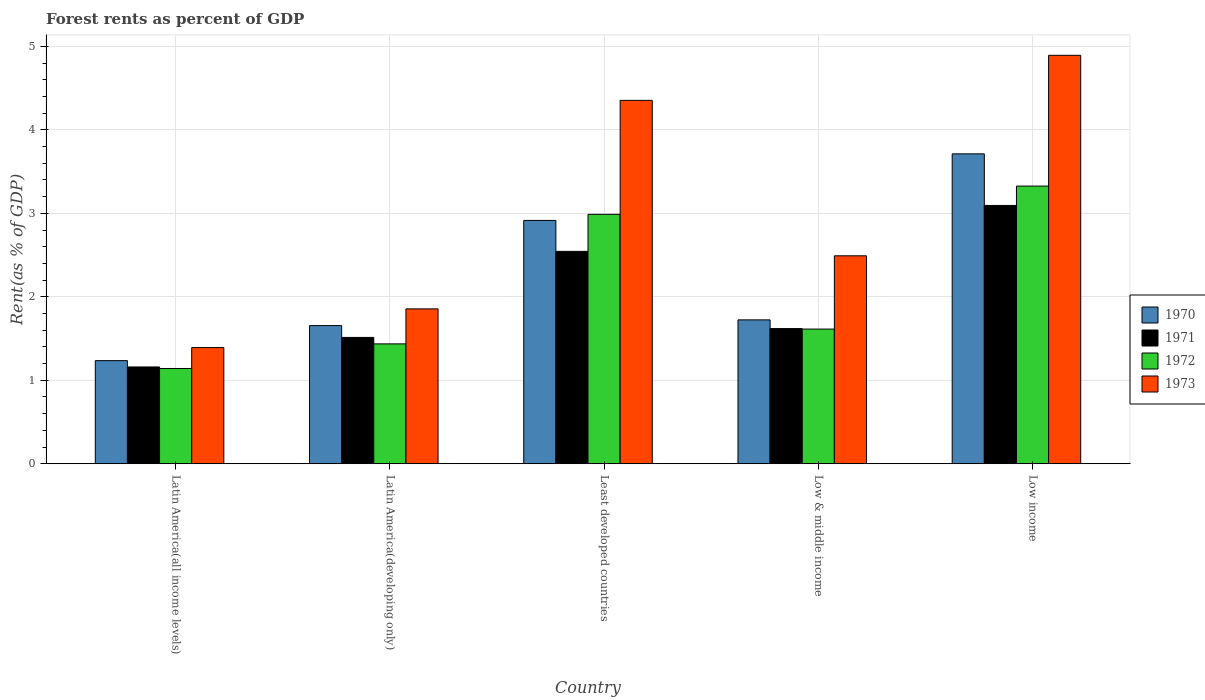How many groups of bars are there?
Make the answer very short. 5. Are the number of bars on each tick of the X-axis equal?
Provide a succinct answer. Yes. How many bars are there on the 4th tick from the left?
Offer a terse response. 4. How many bars are there on the 3rd tick from the right?
Give a very brief answer. 4. In how many cases, is the number of bars for a given country not equal to the number of legend labels?
Ensure brevity in your answer.  0. What is the forest rent in 1972 in Least developed countries?
Give a very brief answer. 2.99. Across all countries, what is the maximum forest rent in 1971?
Give a very brief answer. 3.09. Across all countries, what is the minimum forest rent in 1970?
Make the answer very short. 1.24. In which country was the forest rent in 1971 maximum?
Provide a succinct answer. Low income. In which country was the forest rent in 1971 minimum?
Offer a terse response. Latin America(all income levels). What is the total forest rent in 1970 in the graph?
Offer a terse response. 11.24. What is the difference between the forest rent in 1973 in Least developed countries and that in Low income?
Make the answer very short. -0.54. What is the difference between the forest rent in 1973 in Latin America(all income levels) and the forest rent in 1971 in Least developed countries?
Your response must be concise. -1.15. What is the average forest rent in 1970 per country?
Keep it short and to the point. 2.25. What is the difference between the forest rent of/in 1973 and forest rent of/in 1971 in Latin America(developing only)?
Give a very brief answer. 0.34. In how many countries, is the forest rent in 1970 greater than 0.4 %?
Give a very brief answer. 5. What is the ratio of the forest rent in 1973 in Latin America(developing only) to that in Low income?
Your response must be concise. 0.38. Is the forest rent in 1971 in Latin America(all income levels) less than that in Low income?
Offer a very short reply. Yes. What is the difference between the highest and the second highest forest rent in 1970?
Make the answer very short. -1.19. What is the difference between the highest and the lowest forest rent in 1970?
Your answer should be compact. 2.48. In how many countries, is the forest rent in 1970 greater than the average forest rent in 1970 taken over all countries?
Provide a succinct answer. 2. Is it the case that in every country, the sum of the forest rent in 1972 and forest rent in 1970 is greater than the sum of forest rent in 1971 and forest rent in 1973?
Your response must be concise. No. How many bars are there?
Offer a very short reply. 20. How many countries are there in the graph?
Your answer should be very brief. 5. What is the difference between two consecutive major ticks on the Y-axis?
Make the answer very short. 1. Does the graph contain any zero values?
Keep it short and to the point. No. How many legend labels are there?
Give a very brief answer. 4. What is the title of the graph?
Your response must be concise. Forest rents as percent of GDP. What is the label or title of the X-axis?
Give a very brief answer. Country. What is the label or title of the Y-axis?
Provide a short and direct response. Rent(as % of GDP). What is the Rent(as % of GDP) in 1970 in Latin America(all income levels)?
Offer a terse response. 1.24. What is the Rent(as % of GDP) in 1971 in Latin America(all income levels)?
Give a very brief answer. 1.16. What is the Rent(as % of GDP) in 1972 in Latin America(all income levels)?
Ensure brevity in your answer.  1.14. What is the Rent(as % of GDP) in 1973 in Latin America(all income levels)?
Provide a succinct answer. 1.39. What is the Rent(as % of GDP) of 1970 in Latin America(developing only)?
Provide a short and direct response. 1.66. What is the Rent(as % of GDP) in 1971 in Latin America(developing only)?
Your response must be concise. 1.51. What is the Rent(as % of GDP) of 1972 in Latin America(developing only)?
Make the answer very short. 1.44. What is the Rent(as % of GDP) of 1973 in Latin America(developing only)?
Provide a short and direct response. 1.86. What is the Rent(as % of GDP) of 1970 in Least developed countries?
Offer a very short reply. 2.92. What is the Rent(as % of GDP) in 1971 in Least developed countries?
Ensure brevity in your answer.  2.54. What is the Rent(as % of GDP) in 1972 in Least developed countries?
Offer a terse response. 2.99. What is the Rent(as % of GDP) of 1973 in Least developed countries?
Your answer should be compact. 4.35. What is the Rent(as % of GDP) in 1970 in Low & middle income?
Keep it short and to the point. 1.72. What is the Rent(as % of GDP) of 1971 in Low & middle income?
Your answer should be very brief. 1.62. What is the Rent(as % of GDP) in 1972 in Low & middle income?
Your answer should be compact. 1.61. What is the Rent(as % of GDP) in 1973 in Low & middle income?
Your answer should be very brief. 2.49. What is the Rent(as % of GDP) in 1970 in Low income?
Your response must be concise. 3.71. What is the Rent(as % of GDP) in 1971 in Low income?
Make the answer very short. 3.09. What is the Rent(as % of GDP) of 1972 in Low income?
Your answer should be very brief. 3.33. What is the Rent(as % of GDP) in 1973 in Low income?
Offer a very short reply. 4.89. Across all countries, what is the maximum Rent(as % of GDP) of 1970?
Your answer should be compact. 3.71. Across all countries, what is the maximum Rent(as % of GDP) of 1971?
Provide a succinct answer. 3.09. Across all countries, what is the maximum Rent(as % of GDP) of 1972?
Provide a succinct answer. 3.33. Across all countries, what is the maximum Rent(as % of GDP) of 1973?
Your answer should be compact. 4.89. Across all countries, what is the minimum Rent(as % of GDP) of 1970?
Make the answer very short. 1.24. Across all countries, what is the minimum Rent(as % of GDP) of 1971?
Offer a very short reply. 1.16. Across all countries, what is the minimum Rent(as % of GDP) in 1972?
Offer a very short reply. 1.14. Across all countries, what is the minimum Rent(as % of GDP) in 1973?
Keep it short and to the point. 1.39. What is the total Rent(as % of GDP) of 1970 in the graph?
Your answer should be compact. 11.24. What is the total Rent(as % of GDP) of 1971 in the graph?
Provide a short and direct response. 9.93. What is the total Rent(as % of GDP) of 1972 in the graph?
Provide a succinct answer. 10.51. What is the total Rent(as % of GDP) in 1973 in the graph?
Provide a succinct answer. 14.99. What is the difference between the Rent(as % of GDP) of 1970 in Latin America(all income levels) and that in Latin America(developing only)?
Your answer should be very brief. -0.42. What is the difference between the Rent(as % of GDP) in 1971 in Latin America(all income levels) and that in Latin America(developing only)?
Your response must be concise. -0.35. What is the difference between the Rent(as % of GDP) of 1972 in Latin America(all income levels) and that in Latin America(developing only)?
Your answer should be very brief. -0.29. What is the difference between the Rent(as % of GDP) of 1973 in Latin America(all income levels) and that in Latin America(developing only)?
Offer a very short reply. -0.46. What is the difference between the Rent(as % of GDP) of 1970 in Latin America(all income levels) and that in Least developed countries?
Your response must be concise. -1.68. What is the difference between the Rent(as % of GDP) in 1971 in Latin America(all income levels) and that in Least developed countries?
Provide a short and direct response. -1.39. What is the difference between the Rent(as % of GDP) in 1972 in Latin America(all income levels) and that in Least developed countries?
Give a very brief answer. -1.85. What is the difference between the Rent(as % of GDP) of 1973 in Latin America(all income levels) and that in Least developed countries?
Offer a very short reply. -2.96. What is the difference between the Rent(as % of GDP) in 1970 in Latin America(all income levels) and that in Low & middle income?
Your answer should be very brief. -0.49. What is the difference between the Rent(as % of GDP) of 1971 in Latin America(all income levels) and that in Low & middle income?
Offer a very short reply. -0.46. What is the difference between the Rent(as % of GDP) in 1972 in Latin America(all income levels) and that in Low & middle income?
Provide a short and direct response. -0.47. What is the difference between the Rent(as % of GDP) of 1973 in Latin America(all income levels) and that in Low & middle income?
Your answer should be very brief. -1.1. What is the difference between the Rent(as % of GDP) in 1970 in Latin America(all income levels) and that in Low income?
Ensure brevity in your answer.  -2.48. What is the difference between the Rent(as % of GDP) of 1971 in Latin America(all income levels) and that in Low income?
Your answer should be compact. -1.94. What is the difference between the Rent(as % of GDP) of 1972 in Latin America(all income levels) and that in Low income?
Give a very brief answer. -2.19. What is the difference between the Rent(as % of GDP) of 1973 in Latin America(all income levels) and that in Low income?
Your answer should be compact. -3.5. What is the difference between the Rent(as % of GDP) of 1970 in Latin America(developing only) and that in Least developed countries?
Keep it short and to the point. -1.26. What is the difference between the Rent(as % of GDP) in 1971 in Latin America(developing only) and that in Least developed countries?
Keep it short and to the point. -1.03. What is the difference between the Rent(as % of GDP) in 1972 in Latin America(developing only) and that in Least developed countries?
Ensure brevity in your answer.  -1.55. What is the difference between the Rent(as % of GDP) in 1973 in Latin America(developing only) and that in Least developed countries?
Your response must be concise. -2.5. What is the difference between the Rent(as % of GDP) in 1970 in Latin America(developing only) and that in Low & middle income?
Provide a short and direct response. -0.07. What is the difference between the Rent(as % of GDP) of 1971 in Latin America(developing only) and that in Low & middle income?
Keep it short and to the point. -0.11. What is the difference between the Rent(as % of GDP) in 1972 in Latin America(developing only) and that in Low & middle income?
Your answer should be compact. -0.18. What is the difference between the Rent(as % of GDP) in 1973 in Latin America(developing only) and that in Low & middle income?
Keep it short and to the point. -0.64. What is the difference between the Rent(as % of GDP) in 1970 in Latin America(developing only) and that in Low income?
Give a very brief answer. -2.06. What is the difference between the Rent(as % of GDP) in 1971 in Latin America(developing only) and that in Low income?
Give a very brief answer. -1.58. What is the difference between the Rent(as % of GDP) in 1972 in Latin America(developing only) and that in Low income?
Provide a succinct answer. -1.89. What is the difference between the Rent(as % of GDP) of 1973 in Latin America(developing only) and that in Low income?
Your answer should be compact. -3.04. What is the difference between the Rent(as % of GDP) in 1970 in Least developed countries and that in Low & middle income?
Provide a succinct answer. 1.19. What is the difference between the Rent(as % of GDP) of 1971 in Least developed countries and that in Low & middle income?
Ensure brevity in your answer.  0.93. What is the difference between the Rent(as % of GDP) in 1972 in Least developed countries and that in Low & middle income?
Offer a very short reply. 1.37. What is the difference between the Rent(as % of GDP) in 1973 in Least developed countries and that in Low & middle income?
Offer a terse response. 1.86. What is the difference between the Rent(as % of GDP) of 1970 in Least developed countries and that in Low income?
Your answer should be compact. -0.8. What is the difference between the Rent(as % of GDP) in 1971 in Least developed countries and that in Low income?
Provide a succinct answer. -0.55. What is the difference between the Rent(as % of GDP) in 1972 in Least developed countries and that in Low income?
Make the answer very short. -0.34. What is the difference between the Rent(as % of GDP) of 1973 in Least developed countries and that in Low income?
Offer a terse response. -0.54. What is the difference between the Rent(as % of GDP) in 1970 in Low & middle income and that in Low income?
Your answer should be very brief. -1.99. What is the difference between the Rent(as % of GDP) in 1971 in Low & middle income and that in Low income?
Your answer should be very brief. -1.48. What is the difference between the Rent(as % of GDP) of 1972 in Low & middle income and that in Low income?
Keep it short and to the point. -1.71. What is the difference between the Rent(as % of GDP) in 1973 in Low & middle income and that in Low income?
Your answer should be compact. -2.4. What is the difference between the Rent(as % of GDP) in 1970 in Latin America(all income levels) and the Rent(as % of GDP) in 1971 in Latin America(developing only)?
Offer a terse response. -0.28. What is the difference between the Rent(as % of GDP) of 1970 in Latin America(all income levels) and the Rent(as % of GDP) of 1972 in Latin America(developing only)?
Offer a terse response. -0.2. What is the difference between the Rent(as % of GDP) of 1970 in Latin America(all income levels) and the Rent(as % of GDP) of 1973 in Latin America(developing only)?
Provide a succinct answer. -0.62. What is the difference between the Rent(as % of GDP) in 1971 in Latin America(all income levels) and the Rent(as % of GDP) in 1972 in Latin America(developing only)?
Your answer should be compact. -0.28. What is the difference between the Rent(as % of GDP) of 1971 in Latin America(all income levels) and the Rent(as % of GDP) of 1973 in Latin America(developing only)?
Offer a terse response. -0.7. What is the difference between the Rent(as % of GDP) of 1972 in Latin America(all income levels) and the Rent(as % of GDP) of 1973 in Latin America(developing only)?
Keep it short and to the point. -0.71. What is the difference between the Rent(as % of GDP) in 1970 in Latin America(all income levels) and the Rent(as % of GDP) in 1971 in Least developed countries?
Make the answer very short. -1.31. What is the difference between the Rent(as % of GDP) of 1970 in Latin America(all income levels) and the Rent(as % of GDP) of 1972 in Least developed countries?
Give a very brief answer. -1.75. What is the difference between the Rent(as % of GDP) in 1970 in Latin America(all income levels) and the Rent(as % of GDP) in 1973 in Least developed countries?
Provide a succinct answer. -3.12. What is the difference between the Rent(as % of GDP) of 1971 in Latin America(all income levels) and the Rent(as % of GDP) of 1972 in Least developed countries?
Offer a terse response. -1.83. What is the difference between the Rent(as % of GDP) of 1971 in Latin America(all income levels) and the Rent(as % of GDP) of 1973 in Least developed countries?
Keep it short and to the point. -3.19. What is the difference between the Rent(as % of GDP) in 1972 in Latin America(all income levels) and the Rent(as % of GDP) in 1973 in Least developed countries?
Provide a short and direct response. -3.21. What is the difference between the Rent(as % of GDP) in 1970 in Latin America(all income levels) and the Rent(as % of GDP) in 1971 in Low & middle income?
Provide a short and direct response. -0.38. What is the difference between the Rent(as % of GDP) of 1970 in Latin America(all income levels) and the Rent(as % of GDP) of 1972 in Low & middle income?
Give a very brief answer. -0.38. What is the difference between the Rent(as % of GDP) in 1970 in Latin America(all income levels) and the Rent(as % of GDP) in 1973 in Low & middle income?
Your response must be concise. -1.26. What is the difference between the Rent(as % of GDP) of 1971 in Latin America(all income levels) and the Rent(as % of GDP) of 1972 in Low & middle income?
Keep it short and to the point. -0.45. What is the difference between the Rent(as % of GDP) of 1971 in Latin America(all income levels) and the Rent(as % of GDP) of 1973 in Low & middle income?
Provide a short and direct response. -1.33. What is the difference between the Rent(as % of GDP) in 1972 in Latin America(all income levels) and the Rent(as % of GDP) in 1973 in Low & middle income?
Provide a short and direct response. -1.35. What is the difference between the Rent(as % of GDP) in 1970 in Latin America(all income levels) and the Rent(as % of GDP) in 1971 in Low income?
Make the answer very short. -1.86. What is the difference between the Rent(as % of GDP) in 1970 in Latin America(all income levels) and the Rent(as % of GDP) in 1972 in Low income?
Give a very brief answer. -2.09. What is the difference between the Rent(as % of GDP) in 1970 in Latin America(all income levels) and the Rent(as % of GDP) in 1973 in Low income?
Your answer should be compact. -3.66. What is the difference between the Rent(as % of GDP) of 1971 in Latin America(all income levels) and the Rent(as % of GDP) of 1972 in Low income?
Give a very brief answer. -2.17. What is the difference between the Rent(as % of GDP) in 1971 in Latin America(all income levels) and the Rent(as % of GDP) in 1973 in Low income?
Make the answer very short. -3.73. What is the difference between the Rent(as % of GDP) of 1972 in Latin America(all income levels) and the Rent(as % of GDP) of 1973 in Low income?
Give a very brief answer. -3.75. What is the difference between the Rent(as % of GDP) in 1970 in Latin America(developing only) and the Rent(as % of GDP) in 1971 in Least developed countries?
Your answer should be compact. -0.89. What is the difference between the Rent(as % of GDP) in 1970 in Latin America(developing only) and the Rent(as % of GDP) in 1972 in Least developed countries?
Ensure brevity in your answer.  -1.33. What is the difference between the Rent(as % of GDP) in 1970 in Latin America(developing only) and the Rent(as % of GDP) in 1973 in Least developed countries?
Provide a succinct answer. -2.7. What is the difference between the Rent(as % of GDP) of 1971 in Latin America(developing only) and the Rent(as % of GDP) of 1972 in Least developed countries?
Offer a very short reply. -1.47. What is the difference between the Rent(as % of GDP) in 1971 in Latin America(developing only) and the Rent(as % of GDP) in 1973 in Least developed countries?
Keep it short and to the point. -2.84. What is the difference between the Rent(as % of GDP) in 1972 in Latin America(developing only) and the Rent(as % of GDP) in 1973 in Least developed countries?
Offer a terse response. -2.92. What is the difference between the Rent(as % of GDP) of 1970 in Latin America(developing only) and the Rent(as % of GDP) of 1971 in Low & middle income?
Provide a short and direct response. 0.04. What is the difference between the Rent(as % of GDP) of 1970 in Latin America(developing only) and the Rent(as % of GDP) of 1972 in Low & middle income?
Offer a terse response. 0.04. What is the difference between the Rent(as % of GDP) of 1970 in Latin America(developing only) and the Rent(as % of GDP) of 1973 in Low & middle income?
Provide a short and direct response. -0.84. What is the difference between the Rent(as % of GDP) of 1971 in Latin America(developing only) and the Rent(as % of GDP) of 1972 in Low & middle income?
Your response must be concise. -0.1. What is the difference between the Rent(as % of GDP) in 1971 in Latin America(developing only) and the Rent(as % of GDP) in 1973 in Low & middle income?
Provide a succinct answer. -0.98. What is the difference between the Rent(as % of GDP) in 1972 in Latin America(developing only) and the Rent(as % of GDP) in 1973 in Low & middle income?
Offer a terse response. -1.06. What is the difference between the Rent(as % of GDP) of 1970 in Latin America(developing only) and the Rent(as % of GDP) of 1971 in Low income?
Provide a short and direct response. -1.44. What is the difference between the Rent(as % of GDP) of 1970 in Latin America(developing only) and the Rent(as % of GDP) of 1972 in Low income?
Make the answer very short. -1.67. What is the difference between the Rent(as % of GDP) in 1970 in Latin America(developing only) and the Rent(as % of GDP) in 1973 in Low income?
Your answer should be very brief. -3.24. What is the difference between the Rent(as % of GDP) of 1971 in Latin America(developing only) and the Rent(as % of GDP) of 1972 in Low income?
Offer a very short reply. -1.81. What is the difference between the Rent(as % of GDP) in 1971 in Latin America(developing only) and the Rent(as % of GDP) in 1973 in Low income?
Provide a succinct answer. -3.38. What is the difference between the Rent(as % of GDP) of 1972 in Latin America(developing only) and the Rent(as % of GDP) of 1973 in Low income?
Offer a terse response. -3.46. What is the difference between the Rent(as % of GDP) in 1970 in Least developed countries and the Rent(as % of GDP) in 1971 in Low & middle income?
Provide a succinct answer. 1.3. What is the difference between the Rent(as % of GDP) in 1970 in Least developed countries and the Rent(as % of GDP) in 1972 in Low & middle income?
Provide a short and direct response. 1.3. What is the difference between the Rent(as % of GDP) of 1970 in Least developed countries and the Rent(as % of GDP) of 1973 in Low & middle income?
Make the answer very short. 0.42. What is the difference between the Rent(as % of GDP) in 1971 in Least developed countries and the Rent(as % of GDP) in 1972 in Low & middle income?
Your response must be concise. 0.93. What is the difference between the Rent(as % of GDP) of 1971 in Least developed countries and the Rent(as % of GDP) of 1973 in Low & middle income?
Give a very brief answer. 0.05. What is the difference between the Rent(as % of GDP) in 1972 in Least developed countries and the Rent(as % of GDP) in 1973 in Low & middle income?
Make the answer very short. 0.5. What is the difference between the Rent(as % of GDP) in 1970 in Least developed countries and the Rent(as % of GDP) in 1971 in Low income?
Provide a succinct answer. -0.18. What is the difference between the Rent(as % of GDP) of 1970 in Least developed countries and the Rent(as % of GDP) of 1972 in Low income?
Ensure brevity in your answer.  -0.41. What is the difference between the Rent(as % of GDP) of 1970 in Least developed countries and the Rent(as % of GDP) of 1973 in Low income?
Offer a very short reply. -1.98. What is the difference between the Rent(as % of GDP) of 1971 in Least developed countries and the Rent(as % of GDP) of 1972 in Low income?
Keep it short and to the point. -0.78. What is the difference between the Rent(as % of GDP) in 1971 in Least developed countries and the Rent(as % of GDP) in 1973 in Low income?
Ensure brevity in your answer.  -2.35. What is the difference between the Rent(as % of GDP) of 1972 in Least developed countries and the Rent(as % of GDP) of 1973 in Low income?
Provide a succinct answer. -1.91. What is the difference between the Rent(as % of GDP) in 1970 in Low & middle income and the Rent(as % of GDP) in 1971 in Low income?
Offer a very short reply. -1.37. What is the difference between the Rent(as % of GDP) of 1970 in Low & middle income and the Rent(as % of GDP) of 1972 in Low income?
Provide a short and direct response. -1.6. What is the difference between the Rent(as % of GDP) of 1970 in Low & middle income and the Rent(as % of GDP) of 1973 in Low income?
Your response must be concise. -3.17. What is the difference between the Rent(as % of GDP) of 1971 in Low & middle income and the Rent(as % of GDP) of 1972 in Low income?
Give a very brief answer. -1.71. What is the difference between the Rent(as % of GDP) in 1971 in Low & middle income and the Rent(as % of GDP) in 1973 in Low income?
Provide a succinct answer. -3.27. What is the difference between the Rent(as % of GDP) of 1972 in Low & middle income and the Rent(as % of GDP) of 1973 in Low income?
Provide a succinct answer. -3.28. What is the average Rent(as % of GDP) in 1970 per country?
Provide a short and direct response. 2.25. What is the average Rent(as % of GDP) in 1971 per country?
Your response must be concise. 1.99. What is the average Rent(as % of GDP) of 1972 per country?
Give a very brief answer. 2.1. What is the average Rent(as % of GDP) in 1973 per country?
Your answer should be compact. 3. What is the difference between the Rent(as % of GDP) of 1970 and Rent(as % of GDP) of 1971 in Latin America(all income levels)?
Offer a very short reply. 0.08. What is the difference between the Rent(as % of GDP) of 1970 and Rent(as % of GDP) of 1972 in Latin America(all income levels)?
Provide a succinct answer. 0.09. What is the difference between the Rent(as % of GDP) of 1970 and Rent(as % of GDP) of 1973 in Latin America(all income levels)?
Provide a succinct answer. -0.16. What is the difference between the Rent(as % of GDP) of 1971 and Rent(as % of GDP) of 1972 in Latin America(all income levels)?
Your answer should be very brief. 0.02. What is the difference between the Rent(as % of GDP) of 1971 and Rent(as % of GDP) of 1973 in Latin America(all income levels)?
Give a very brief answer. -0.23. What is the difference between the Rent(as % of GDP) of 1972 and Rent(as % of GDP) of 1973 in Latin America(all income levels)?
Make the answer very short. -0.25. What is the difference between the Rent(as % of GDP) in 1970 and Rent(as % of GDP) in 1971 in Latin America(developing only)?
Ensure brevity in your answer.  0.14. What is the difference between the Rent(as % of GDP) in 1970 and Rent(as % of GDP) in 1972 in Latin America(developing only)?
Your answer should be compact. 0.22. What is the difference between the Rent(as % of GDP) of 1971 and Rent(as % of GDP) of 1972 in Latin America(developing only)?
Offer a very short reply. 0.08. What is the difference between the Rent(as % of GDP) in 1971 and Rent(as % of GDP) in 1973 in Latin America(developing only)?
Give a very brief answer. -0.34. What is the difference between the Rent(as % of GDP) in 1972 and Rent(as % of GDP) in 1973 in Latin America(developing only)?
Your response must be concise. -0.42. What is the difference between the Rent(as % of GDP) in 1970 and Rent(as % of GDP) in 1971 in Least developed countries?
Give a very brief answer. 0.37. What is the difference between the Rent(as % of GDP) in 1970 and Rent(as % of GDP) in 1972 in Least developed countries?
Your response must be concise. -0.07. What is the difference between the Rent(as % of GDP) in 1970 and Rent(as % of GDP) in 1973 in Least developed countries?
Ensure brevity in your answer.  -1.44. What is the difference between the Rent(as % of GDP) in 1971 and Rent(as % of GDP) in 1972 in Least developed countries?
Provide a succinct answer. -0.44. What is the difference between the Rent(as % of GDP) in 1971 and Rent(as % of GDP) in 1973 in Least developed countries?
Ensure brevity in your answer.  -1.81. What is the difference between the Rent(as % of GDP) in 1972 and Rent(as % of GDP) in 1973 in Least developed countries?
Offer a terse response. -1.37. What is the difference between the Rent(as % of GDP) of 1970 and Rent(as % of GDP) of 1971 in Low & middle income?
Provide a short and direct response. 0.1. What is the difference between the Rent(as % of GDP) in 1970 and Rent(as % of GDP) in 1972 in Low & middle income?
Provide a succinct answer. 0.11. What is the difference between the Rent(as % of GDP) in 1970 and Rent(as % of GDP) in 1973 in Low & middle income?
Offer a terse response. -0.77. What is the difference between the Rent(as % of GDP) of 1971 and Rent(as % of GDP) of 1972 in Low & middle income?
Your answer should be compact. 0.01. What is the difference between the Rent(as % of GDP) in 1971 and Rent(as % of GDP) in 1973 in Low & middle income?
Your answer should be very brief. -0.87. What is the difference between the Rent(as % of GDP) in 1972 and Rent(as % of GDP) in 1973 in Low & middle income?
Your answer should be compact. -0.88. What is the difference between the Rent(as % of GDP) in 1970 and Rent(as % of GDP) in 1971 in Low income?
Ensure brevity in your answer.  0.62. What is the difference between the Rent(as % of GDP) of 1970 and Rent(as % of GDP) of 1972 in Low income?
Ensure brevity in your answer.  0.39. What is the difference between the Rent(as % of GDP) in 1970 and Rent(as % of GDP) in 1973 in Low income?
Keep it short and to the point. -1.18. What is the difference between the Rent(as % of GDP) in 1971 and Rent(as % of GDP) in 1972 in Low income?
Your answer should be very brief. -0.23. What is the difference between the Rent(as % of GDP) of 1971 and Rent(as % of GDP) of 1973 in Low income?
Give a very brief answer. -1.8. What is the difference between the Rent(as % of GDP) in 1972 and Rent(as % of GDP) in 1973 in Low income?
Your answer should be very brief. -1.57. What is the ratio of the Rent(as % of GDP) in 1970 in Latin America(all income levels) to that in Latin America(developing only)?
Keep it short and to the point. 0.75. What is the ratio of the Rent(as % of GDP) of 1971 in Latin America(all income levels) to that in Latin America(developing only)?
Provide a short and direct response. 0.77. What is the ratio of the Rent(as % of GDP) in 1972 in Latin America(all income levels) to that in Latin America(developing only)?
Offer a very short reply. 0.79. What is the ratio of the Rent(as % of GDP) in 1973 in Latin America(all income levels) to that in Latin America(developing only)?
Ensure brevity in your answer.  0.75. What is the ratio of the Rent(as % of GDP) of 1970 in Latin America(all income levels) to that in Least developed countries?
Provide a short and direct response. 0.42. What is the ratio of the Rent(as % of GDP) in 1971 in Latin America(all income levels) to that in Least developed countries?
Your answer should be compact. 0.46. What is the ratio of the Rent(as % of GDP) in 1972 in Latin America(all income levels) to that in Least developed countries?
Provide a short and direct response. 0.38. What is the ratio of the Rent(as % of GDP) in 1973 in Latin America(all income levels) to that in Least developed countries?
Offer a very short reply. 0.32. What is the ratio of the Rent(as % of GDP) of 1970 in Latin America(all income levels) to that in Low & middle income?
Keep it short and to the point. 0.72. What is the ratio of the Rent(as % of GDP) of 1971 in Latin America(all income levels) to that in Low & middle income?
Provide a succinct answer. 0.72. What is the ratio of the Rent(as % of GDP) in 1972 in Latin America(all income levels) to that in Low & middle income?
Keep it short and to the point. 0.71. What is the ratio of the Rent(as % of GDP) in 1973 in Latin America(all income levels) to that in Low & middle income?
Offer a terse response. 0.56. What is the ratio of the Rent(as % of GDP) in 1970 in Latin America(all income levels) to that in Low income?
Your answer should be very brief. 0.33. What is the ratio of the Rent(as % of GDP) of 1971 in Latin America(all income levels) to that in Low income?
Your answer should be very brief. 0.37. What is the ratio of the Rent(as % of GDP) of 1972 in Latin America(all income levels) to that in Low income?
Your response must be concise. 0.34. What is the ratio of the Rent(as % of GDP) of 1973 in Latin America(all income levels) to that in Low income?
Provide a succinct answer. 0.28. What is the ratio of the Rent(as % of GDP) of 1970 in Latin America(developing only) to that in Least developed countries?
Give a very brief answer. 0.57. What is the ratio of the Rent(as % of GDP) of 1971 in Latin America(developing only) to that in Least developed countries?
Your answer should be compact. 0.59. What is the ratio of the Rent(as % of GDP) in 1972 in Latin America(developing only) to that in Least developed countries?
Offer a very short reply. 0.48. What is the ratio of the Rent(as % of GDP) in 1973 in Latin America(developing only) to that in Least developed countries?
Keep it short and to the point. 0.43. What is the ratio of the Rent(as % of GDP) of 1970 in Latin America(developing only) to that in Low & middle income?
Your answer should be very brief. 0.96. What is the ratio of the Rent(as % of GDP) in 1971 in Latin America(developing only) to that in Low & middle income?
Your answer should be very brief. 0.93. What is the ratio of the Rent(as % of GDP) in 1972 in Latin America(developing only) to that in Low & middle income?
Provide a short and direct response. 0.89. What is the ratio of the Rent(as % of GDP) of 1973 in Latin America(developing only) to that in Low & middle income?
Make the answer very short. 0.74. What is the ratio of the Rent(as % of GDP) of 1970 in Latin America(developing only) to that in Low income?
Your answer should be very brief. 0.45. What is the ratio of the Rent(as % of GDP) in 1971 in Latin America(developing only) to that in Low income?
Your answer should be compact. 0.49. What is the ratio of the Rent(as % of GDP) in 1972 in Latin America(developing only) to that in Low income?
Offer a terse response. 0.43. What is the ratio of the Rent(as % of GDP) in 1973 in Latin America(developing only) to that in Low income?
Ensure brevity in your answer.  0.38. What is the ratio of the Rent(as % of GDP) of 1970 in Least developed countries to that in Low & middle income?
Your answer should be compact. 1.69. What is the ratio of the Rent(as % of GDP) in 1971 in Least developed countries to that in Low & middle income?
Your answer should be very brief. 1.57. What is the ratio of the Rent(as % of GDP) in 1972 in Least developed countries to that in Low & middle income?
Your answer should be compact. 1.85. What is the ratio of the Rent(as % of GDP) of 1973 in Least developed countries to that in Low & middle income?
Ensure brevity in your answer.  1.75. What is the ratio of the Rent(as % of GDP) in 1970 in Least developed countries to that in Low income?
Give a very brief answer. 0.79. What is the ratio of the Rent(as % of GDP) of 1971 in Least developed countries to that in Low income?
Your response must be concise. 0.82. What is the ratio of the Rent(as % of GDP) of 1972 in Least developed countries to that in Low income?
Keep it short and to the point. 0.9. What is the ratio of the Rent(as % of GDP) in 1973 in Least developed countries to that in Low income?
Offer a very short reply. 0.89. What is the ratio of the Rent(as % of GDP) in 1970 in Low & middle income to that in Low income?
Your answer should be very brief. 0.46. What is the ratio of the Rent(as % of GDP) of 1971 in Low & middle income to that in Low income?
Offer a terse response. 0.52. What is the ratio of the Rent(as % of GDP) in 1972 in Low & middle income to that in Low income?
Ensure brevity in your answer.  0.48. What is the ratio of the Rent(as % of GDP) in 1973 in Low & middle income to that in Low income?
Your response must be concise. 0.51. What is the difference between the highest and the second highest Rent(as % of GDP) in 1970?
Offer a very short reply. 0.8. What is the difference between the highest and the second highest Rent(as % of GDP) in 1971?
Give a very brief answer. 0.55. What is the difference between the highest and the second highest Rent(as % of GDP) of 1972?
Offer a very short reply. 0.34. What is the difference between the highest and the second highest Rent(as % of GDP) of 1973?
Make the answer very short. 0.54. What is the difference between the highest and the lowest Rent(as % of GDP) of 1970?
Your answer should be very brief. 2.48. What is the difference between the highest and the lowest Rent(as % of GDP) in 1971?
Provide a short and direct response. 1.94. What is the difference between the highest and the lowest Rent(as % of GDP) in 1972?
Provide a short and direct response. 2.19. What is the difference between the highest and the lowest Rent(as % of GDP) in 1973?
Make the answer very short. 3.5. 